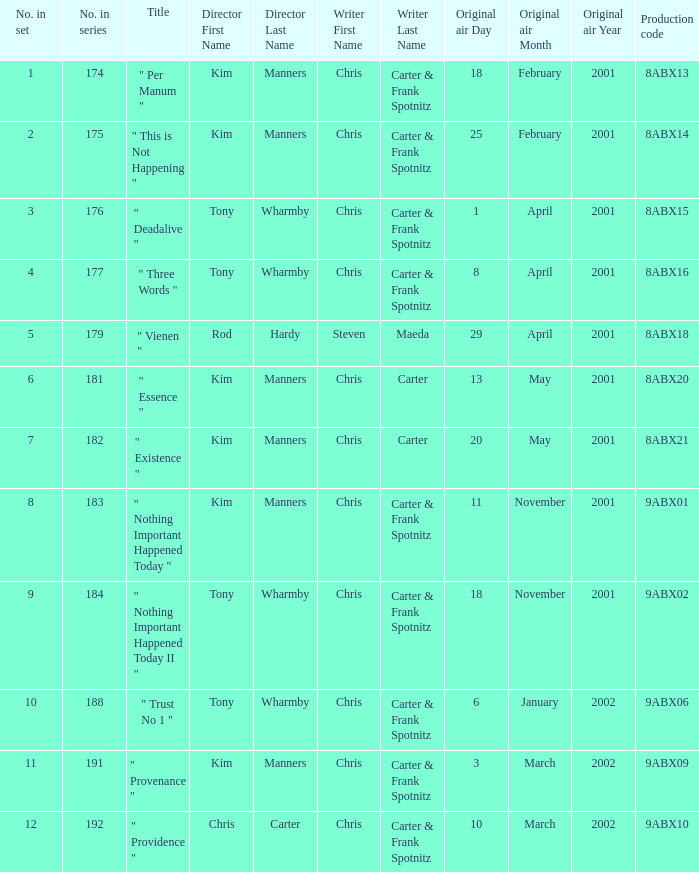The episode with production code 9abx02 was originally aired on what date? November18,2001. 